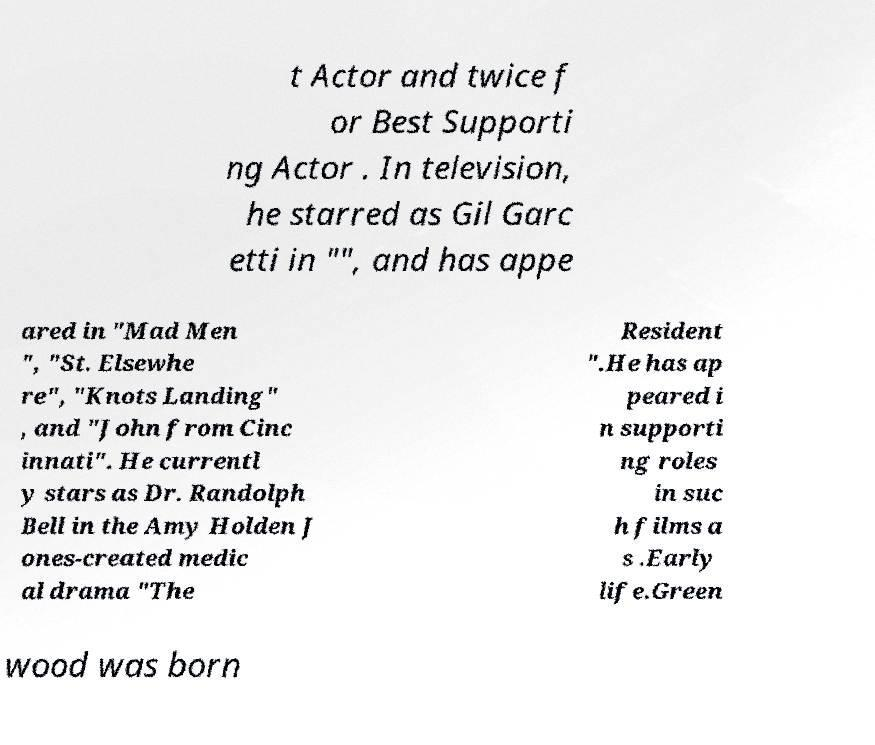Can you read and provide the text displayed in the image?This photo seems to have some interesting text. Can you extract and type it out for me? t Actor and twice f or Best Supporti ng Actor . In television, he starred as Gil Garc etti in "", and has appe ared in "Mad Men ", "St. Elsewhe re", "Knots Landing" , and "John from Cinc innati". He currentl y stars as Dr. Randolph Bell in the Amy Holden J ones-created medic al drama "The Resident ".He has ap peared i n supporti ng roles in suc h films a s .Early life.Green wood was born 